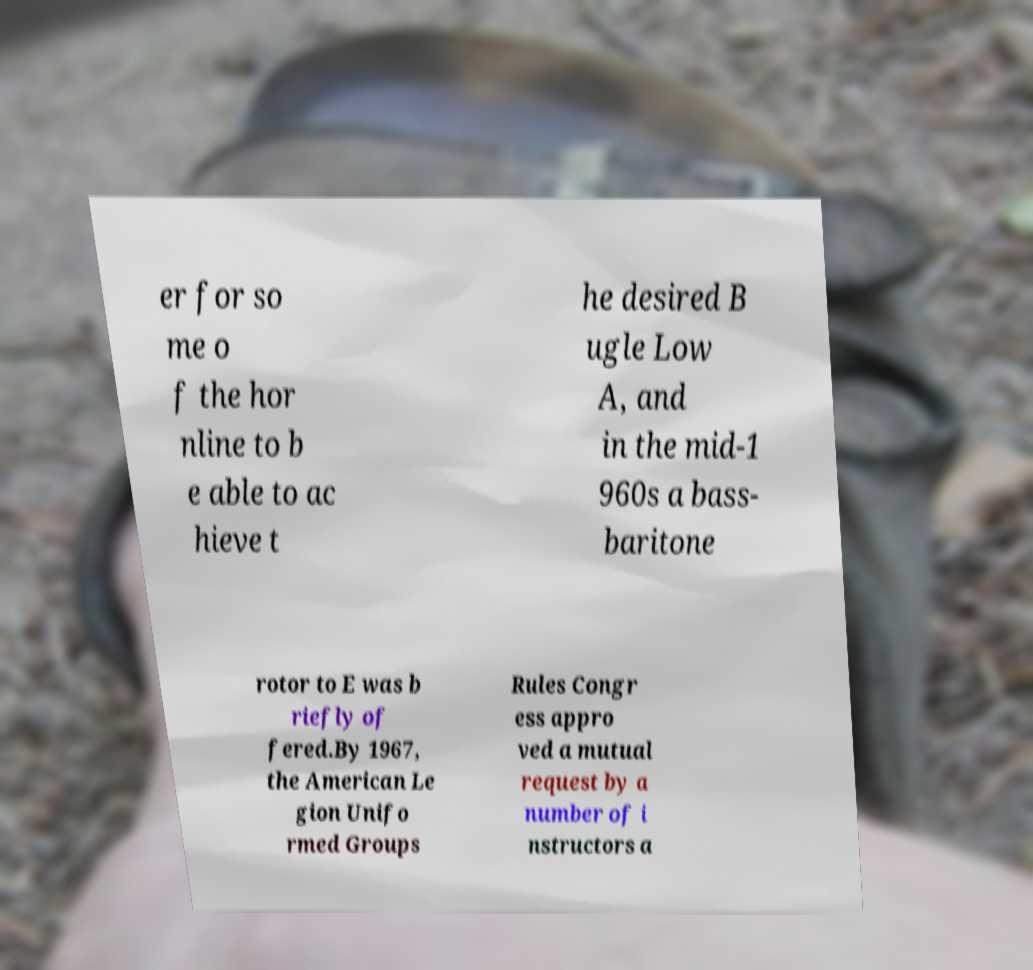For documentation purposes, I need the text within this image transcribed. Could you provide that? er for so me o f the hor nline to b e able to ac hieve t he desired B ugle Low A, and in the mid-1 960s a bass- baritone rotor to E was b riefly of fered.By 1967, the American Le gion Unifo rmed Groups Rules Congr ess appro ved a mutual request by a number of i nstructors a 